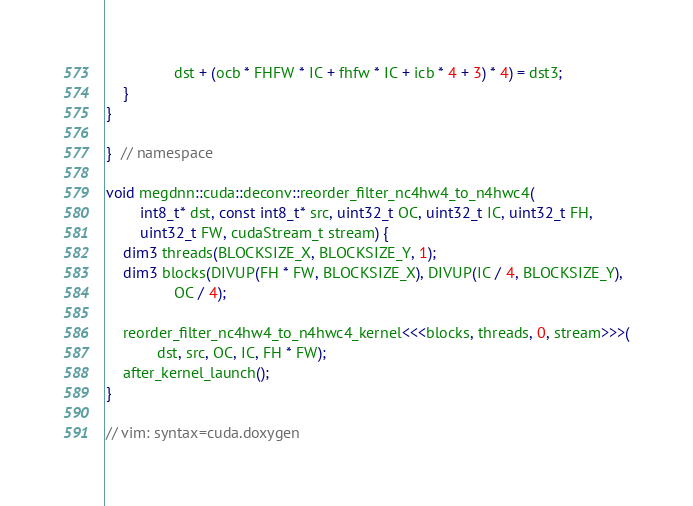Convert code to text. <code><loc_0><loc_0><loc_500><loc_500><_Cuda_>                dst + (ocb * FHFW * IC + fhfw * IC + icb * 4 + 3) * 4) = dst3;
    }
}

}  // namespace

void megdnn::cuda::deconv::reorder_filter_nc4hw4_to_n4hwc4(
        int8_t* dst, const int8_t* src, uint32_t OC, uint32_t IC, uint32_t FH,
        uint32_t FW, cudaStream_t stream) {
    dim3 threads(BLOCKSIZE_X, BLOCKSIZE_Y, 1);
    dim3 blocks(DIVUP(FH * FW, BLOCKSIZE_X), DIVUP(IC / 4, BLOCKSIZE_Y),
                OC / 4);

    reorder_filter_nc4hw4_to_n4hwc4_kernel<<<blocks, threads, 0, stream>>>(
            dst, src, OC, IC, FH * FW);
    after_kernel_launch();
}

// vim: syntax=cuda.doxygen
</code> 